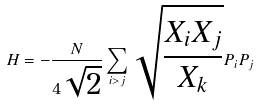Convert formula to latex. <formula><loc_0><loc_0><loc_500><loc_500>H = - \frac { N } { 4 \sqrt { 2 } } \sum _ { i > j } \sqrt { \frac { X _ { i } X _ { j } } { X _ { k } } } P _ { i } P _ { j }</formula> 